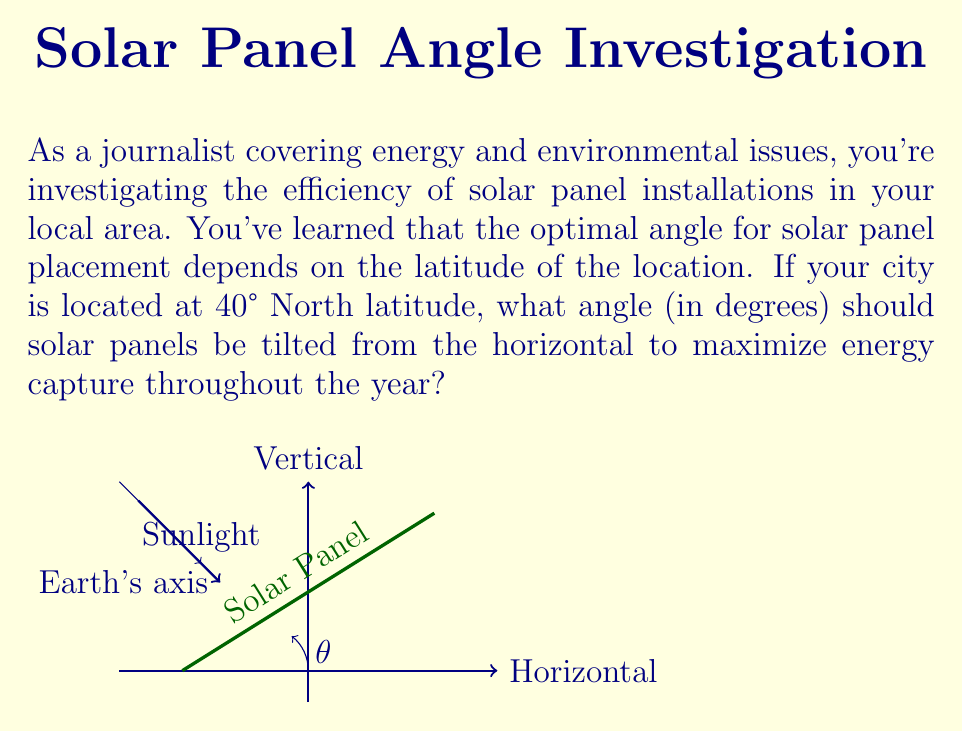Give your solution to this math problem. To determine the optimal angle for solar panel placement, we need to consider the following:

1) The general rule of thumb for fixed solar panels is to tilt them at an angle equal to the latitude of the location.

2) This is because the Earth's axis is tilted at approximately 23.5° relative to its orbit around the Sun.

3) By setting the tilt angle equal to the latitude, we ensure that the panels are perpendicular to the Sun's rays at solar noon during the equinoxes (spring and fall).

4) This approach provides a good compromise between summer and winter sun angles, maximizing year-round energy capture.

5) The optimal angle $\theta$ can be calculated using the simple equation:

   $$\theta = \text{latitude}$$

6) In this case, the city is located at 40° North latitude.

Therefore, the optimal angle for solar panel placement is 40° from the horizontal.

Note: In practice, this angle might be adjusted slightly (usually by subtracting 5-15°) to favor summer production when days are longer and skies are clearer. However, for the purposes of this problem, we'll stick with the basic rule of thumb.
Answer: 40° 